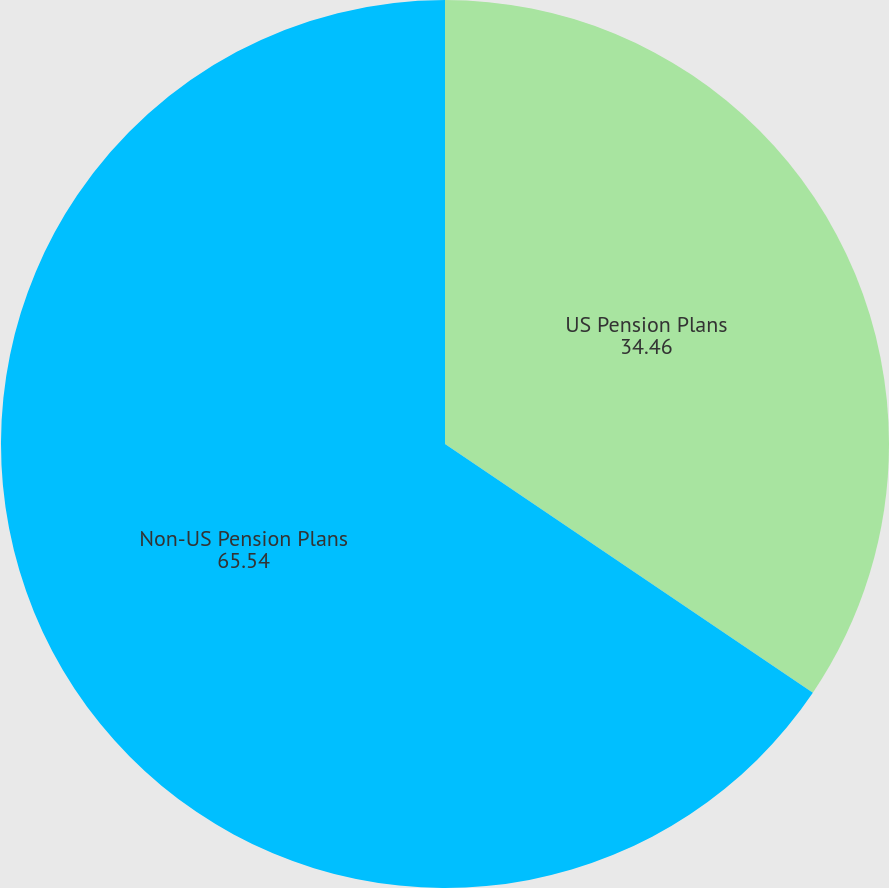Convert chart. <chart><loc_0><loc_0><loc_500><loc_500><pie_chart><fcel>US Pension Plans<fcel>Non-US Pension Plans<nl><fcel>34.46%<fcel>65.54%<nl></chart> 